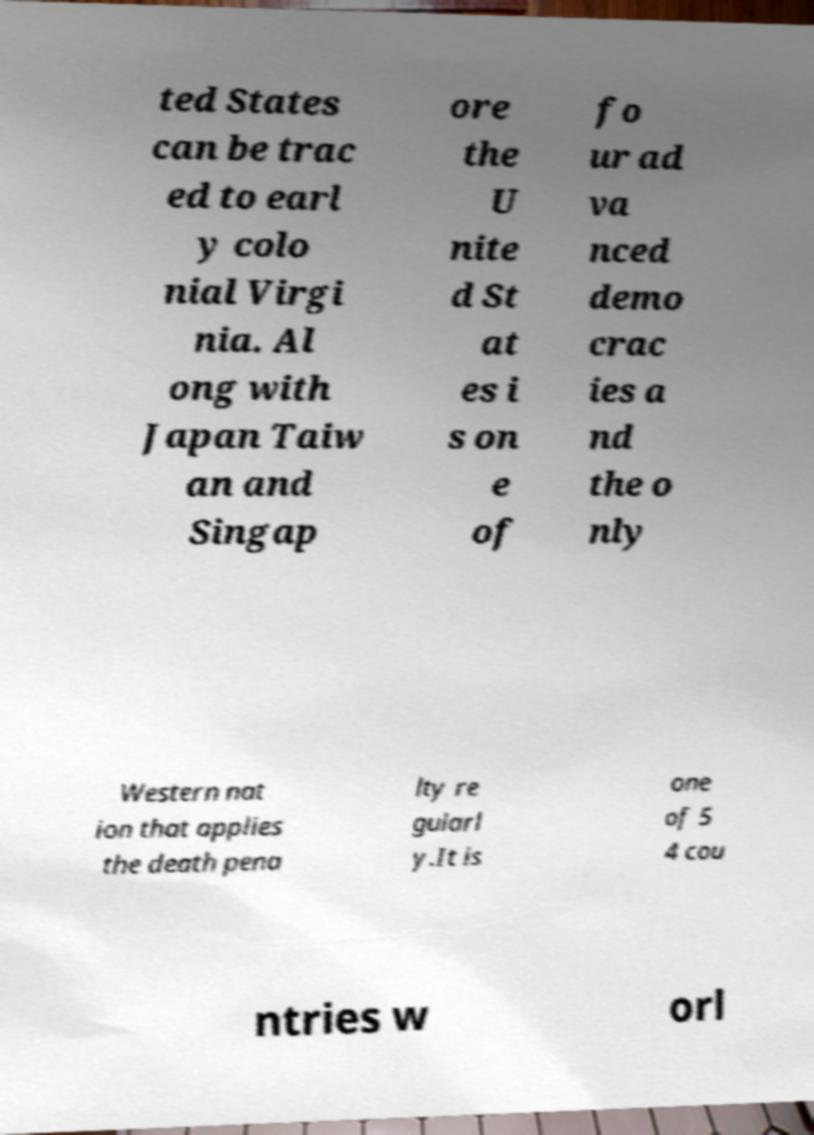Please read and relay the text visible in this image. What does it say? ted States can be trac ed to earl y colo nial Virgi nia. Al ong with Japan Taiw an and Singap ore the U nite d St at es i s on e of fo ur ad va nced demo crac ies a nd the o nly Western nat ion that applies the death pena lty re gularl y.It is one of 5 4 cou ntries w orl 